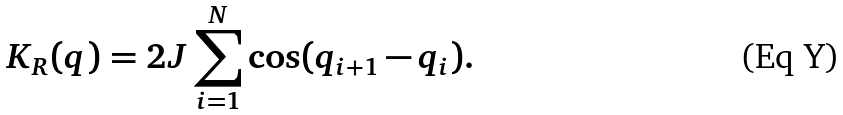<formula> <loc_0><loc_0><loc_500><loc_500>K _ { R } ( q ) = 2 J \sum _ { i = 1 } ^ { N } \cos ( q _ { i + 1 } - q _ { i } ) .</formula> 